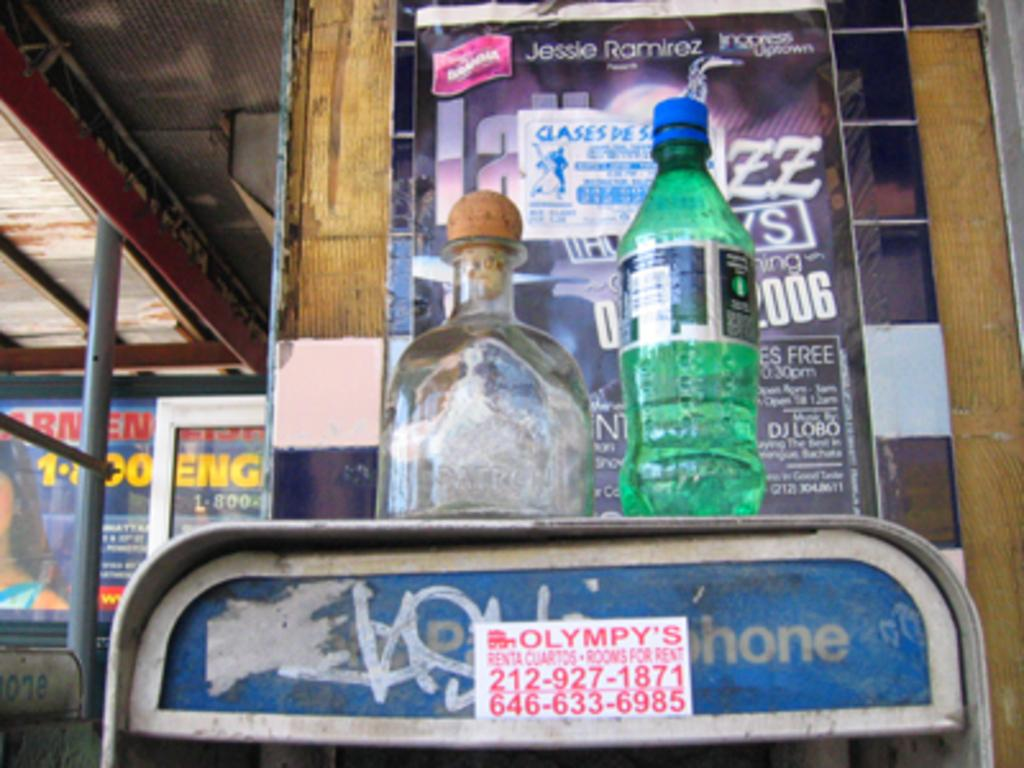<image>
Give a short and clear explanation of the subsequent image. A pay phone that has a sprite bottle and another bottle on top. 